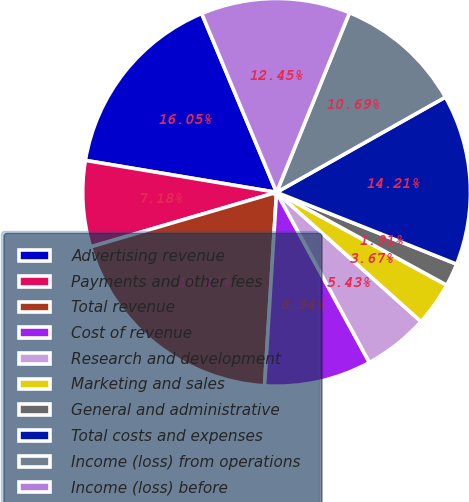Convert chart to OTSL. <chart><loc_0><loc_0><loc_500><loc_500><pie_chart><fcel>Advertising revenue<fcel>Payments and other fees<fcel>Total revenue<fcel>Cost of revenue<fcel>Research and development<fcel>Marketing and sales<fcel>General and administrative<fcel>Total costs and expenses<fcel>Income (loss) from operations<fcel>Income (loss) before<nl><fcel>16.05%<fcel>7.18%<fcel>19.47%<fcel>8.94%<fcel>5.43%<fcel>3.67%<fcel>1.91%<fcel>14.21%<fcel>10.69%<fcel>12.45%<nl></chart> 